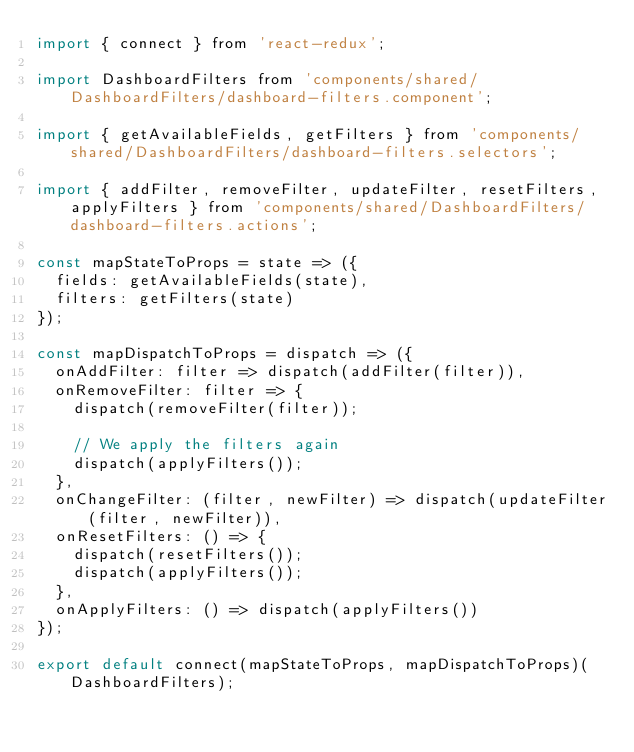<code> <loc_0><loc_0><loc_500><loc_500><_JavaScript_>import { connect } from 'react-redux';

import DashboardFilters from 'components/shared/DashboardFilters/dashboard-filters.component';

import { getAvailableFields, getFilters } from 'components/shared/DashboardFilters/dashboard-filters.selectors';

import { addFilter, removeFilter, updateFilter, resetFilters, applyFilters } from 'components/shared/DashboardFilters/dashboard-filters.actions';

const mapStateToProps = state => ({
  fields: getAvailableFields(state),
  filters: getFilters(state)
});

const mapDispatchToProps = dispatch => ({
  onAddFilter: filter => dispatch(addFilter(filter)),
  onRemoveFilter: filter => {
    dispatch(removeFilter(filter));

    // We apply the filters again
    dispatch(applyFilters());
  },
  onChangeFilter: (filter, newFilter) => dispatch(updateFilter(filter, newFilter)),
  onResetFilters: () => {
    dispatch(resetFilters());
    dispatch(applyFilters());
  },
  onApplyFilters: () => dispatch(applyFilters())
});

export default connect(mapStateToProps, mapDispatchToProps)(DashboardFilters);
</code> 